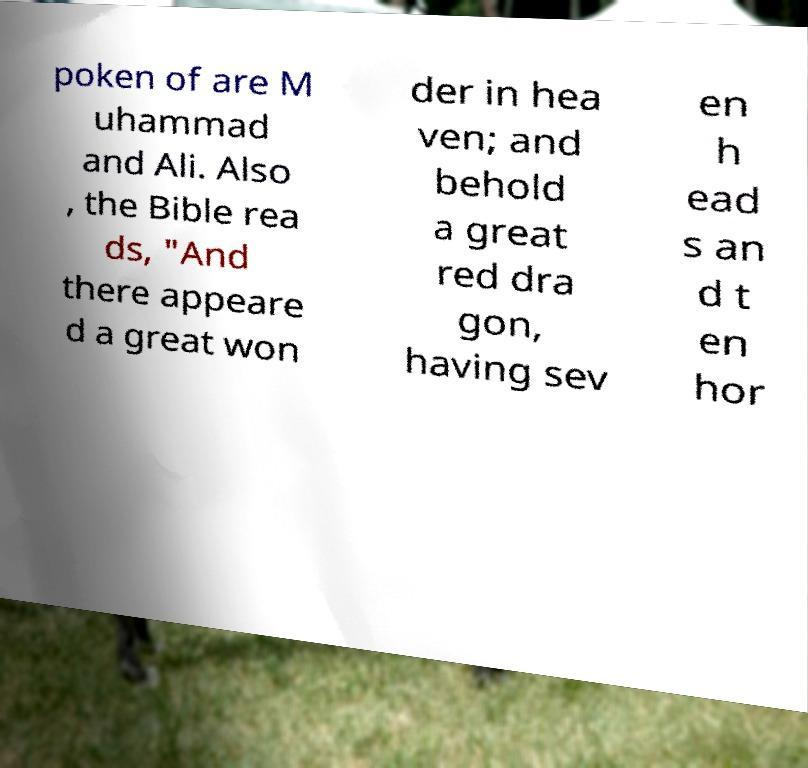Please identify and transcribe the text found in this image. poken of are M uhammad and Ali. Also , the Bible rea ds, "And there appeare d a great won der in hea ven; and behold a great red dra gon, having sev en h ead s an d t en hor 